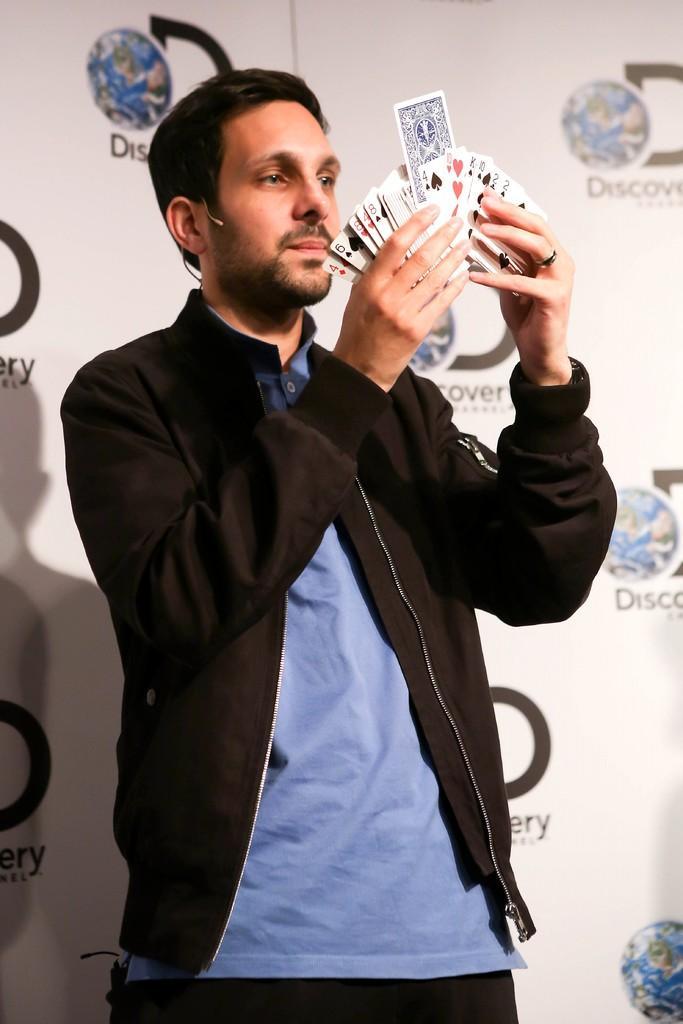In one or two sentences, can you explain what this image depicts? In this image in the center there is one man who is standing and he is holding some cards, and in the background there is a wall. 